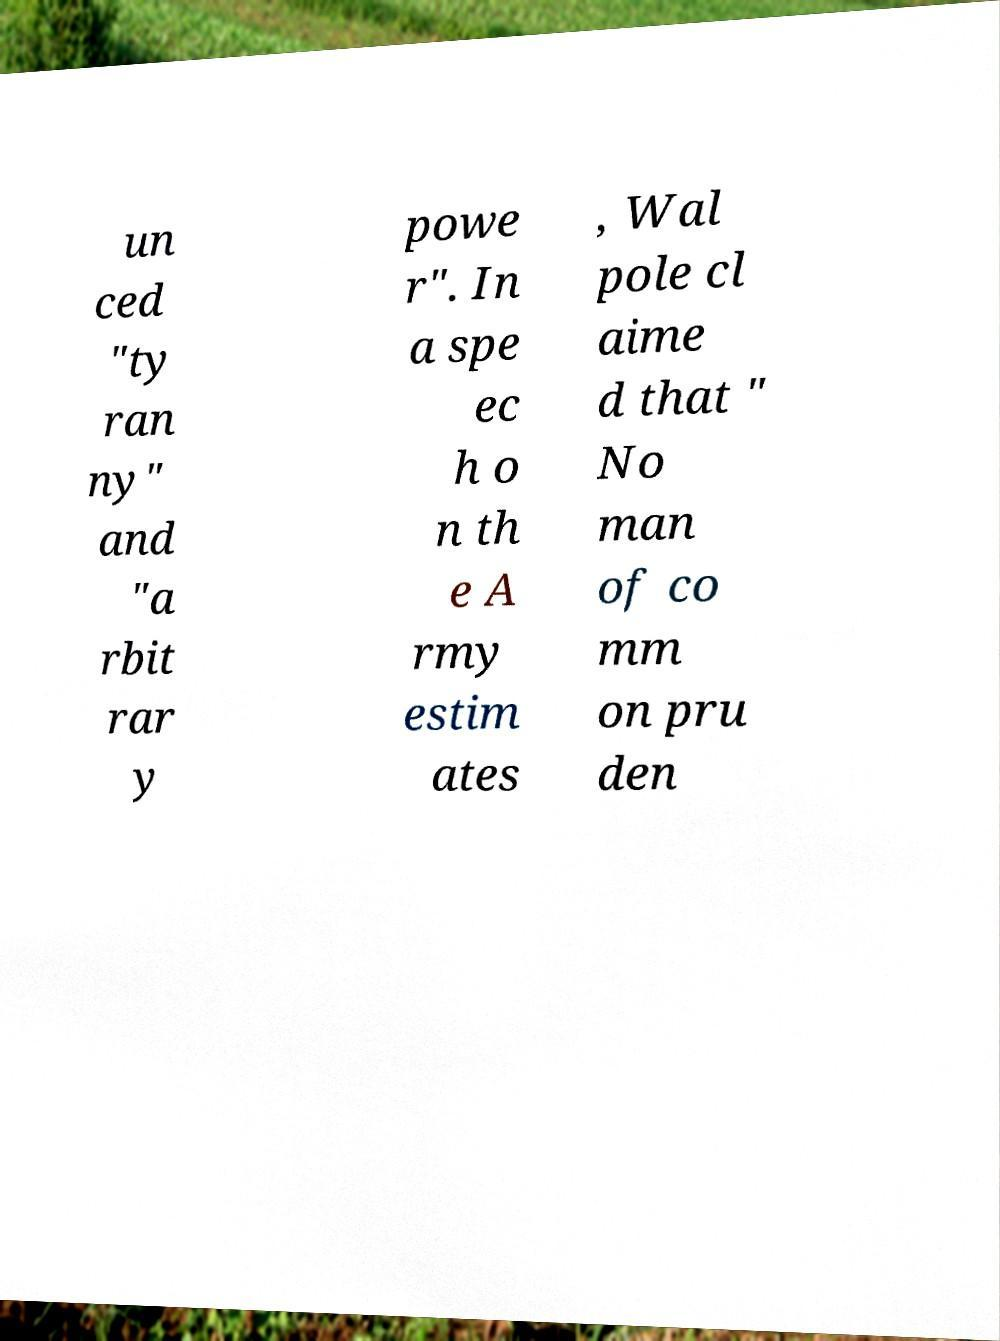There's text embedded in this image that I need extracted. Can you transcribe it verbatim? un ced "ty ran ny" and "a rbit rar y powe r". In a spe ec h o n th e A rmy estim ates , Wal pole cl aime d that " No man of co mm on pru den 